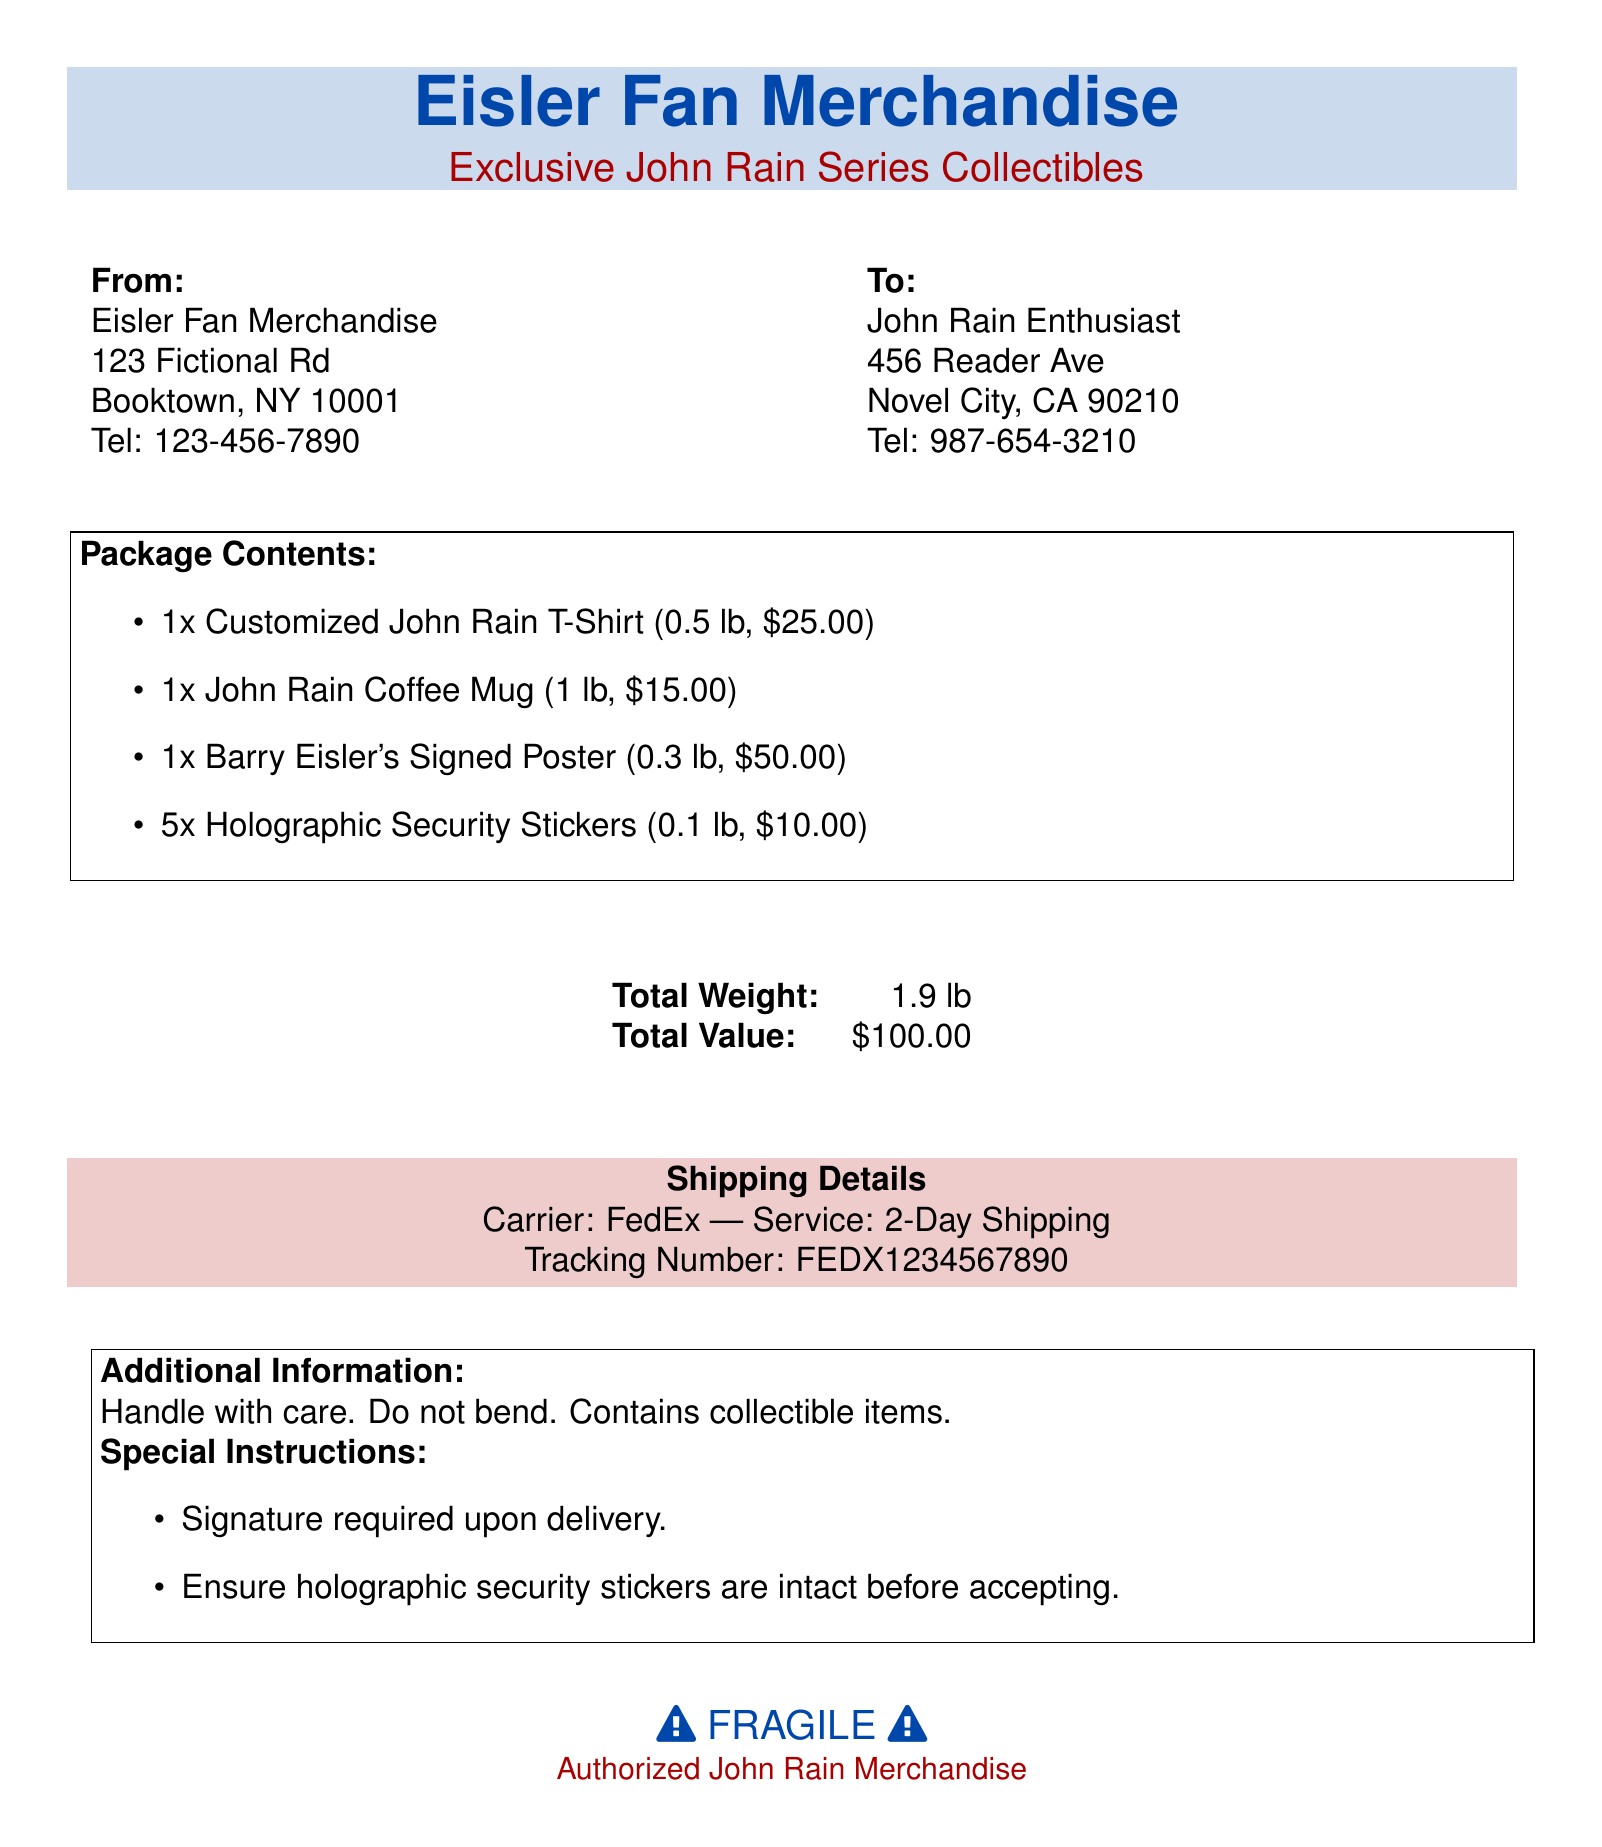What is the total weight of the package? The total weight is specifically provided in the document as the sum of the weights of individual items, which is 1.9 lb.
Answer: 1.9 lb What is the value of the signed poster? The value of the signed poster is listed in the package contents as $50.00.
Answer: $50.00 Who is the recipient of the merchandise? The document provides the name of the recipient in the "To" section, which states "John Rain Enthusiast."
Answer: John Rain Enthusiast How many holographic security stickers are included? The number of holographic security stickers is mentioned in the package contents, which states there are 5 stickers.
Answer: 5 What is the shipping carrier used? The document specifies the carrier in the shipping details section as "FedEx."
Answer: FedEx What is the total value of all items? The total value is calculated as the sum of individual item prices, which is stated to be $100.00 in the document.
Answer: $100.00 What special instruction is required upon delivery? The document indicates a special instruction that states "Signature required upon delivery."
Answer: Signature required upon delivery Which item weighs the most? The weight of individual items is given, making it clear that the "John Rain Coffee Mug" at 1 lb is the heaviest.
Answer: John Rain Coffee Mug 